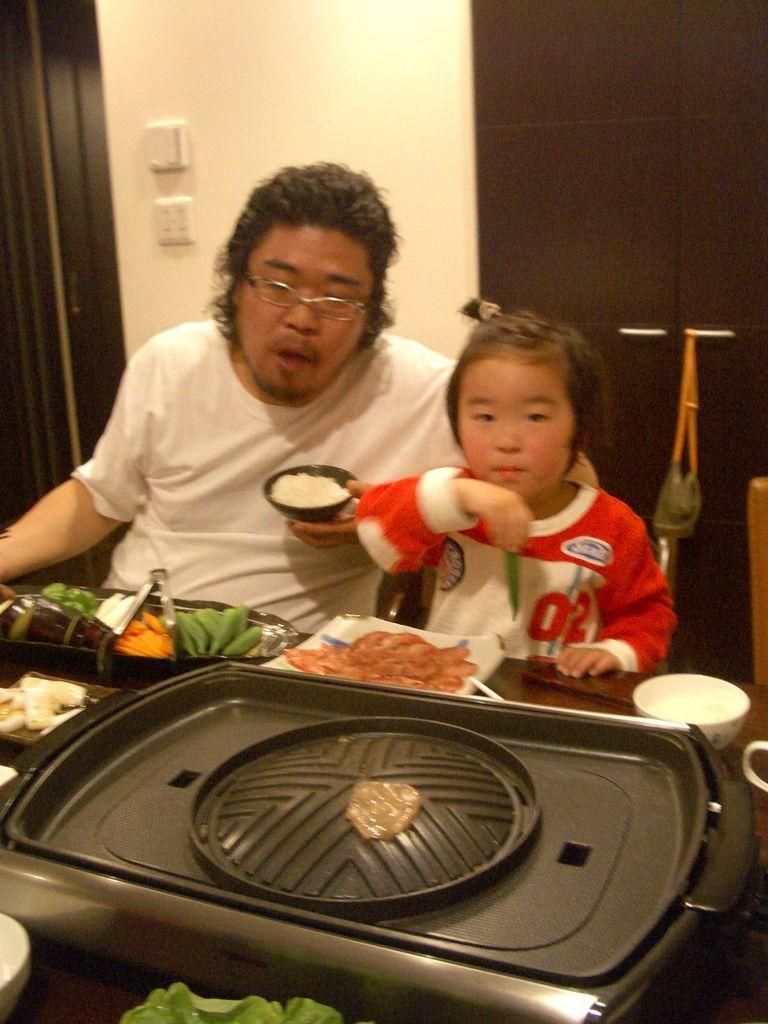Please provide a concise description of this image. In this image we can see a man with the kid in front of a dining table. On the dining table we can see a bowl and also the food items. We can also see the black color object. In the background we can see the wall, wooden shelf, switch boards and also a door. 